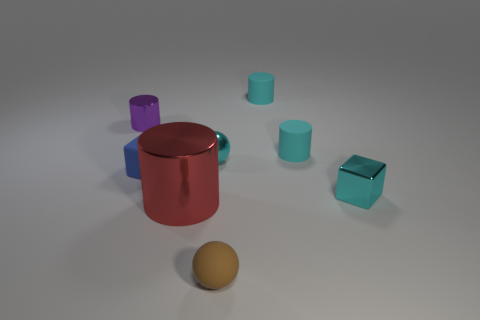Subtract all tiny cylinders. How many cylinders are left? 1 Add 1 large yellow rubber balls. How many large yellow rubber balls exist? 1 Add 1 small cyan metal blocks. How many objects exist? 9 Subtract all cyan cubes. How many cubes are left? 1 Subtract 0 yellow blocks. How many objects are left? 8 Subtract 1 cylinders. How many cylinders are left? 3 Subtract all cyan balls. Subtract all green blocks. How many balls are left? 1 Subtract all brown cubes. How many green cylinders are left? 0 Subtract all brown shiny things. Subtract all small metal cylinders. How many objects are left? 7 Add 4 cyan matte cylinders. How many cyan matte cylinders are left? 6 